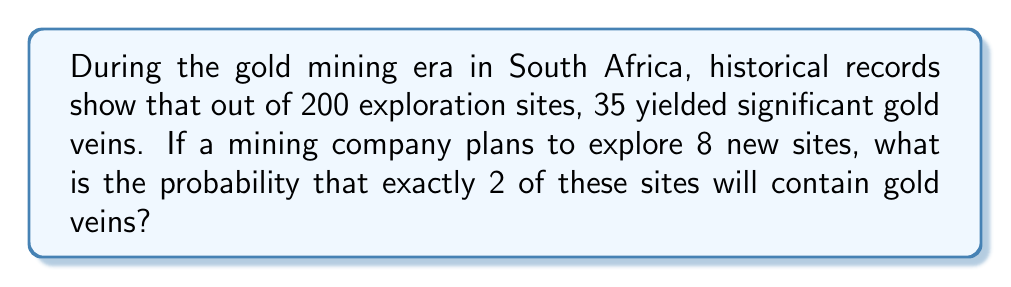What is the answer to this math problem? Let's approach this step-by-step using the binomial probability formula:

1) First, we need to calculate the probability of finding a gold vein at a single site:
   $p = \frac{35}{200} = 0.175$ or 17.5%

2) The probability of not finding a gold vein at a single site is:
   $q = 1 - p = 1 - 0.175 = 0.825$ or 82.5%

3) We want exactly 2 successes out of 8 trials. This follows a binomial distribution.

4) The binomial probability formula is:
   $$P(X = k) = \binom{n}{k} p^k q^{n-k}$$
   where:
   $n$ = number of trials (8)
   $k$ = number of successes (2)
   $p$ = probability of success on each trial (0.175)
   $q$ = probability of failure on each trial (0.825)

5) Let's calculate each part:
   $\binom{8}{2} = \frac{8!}{2!(8-2)!} = \frac{8!}{2!6!} = 28$
   $p^2 = 0.175^2 = 0.030625$
   $q^{8-2} = 0.825^6 = 0.295180$

6) Now, let's put it all together:
   $$P(X = 2) = 28 \times 0.030625 \times 0.295180 = 0.2529$$

Therefore, the probability of finding exactly 2 gold veins in 8 new exploration sites is approximately 0.2529 or 25.29%.
Answer: $0.2529$ or $25.29\%$ 